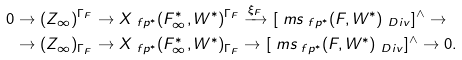Convert formula to latex. <formula><loc_0><loc_0><loc_500><loc_500>0 & \to ( Z _ { \infty } ) ^ { \Gamma _ { F } } \to X _ { \ f p ^ { * } } ( F _ { \infty } ^ { * } , W ^ { * } ) ^ { \Gamma _ { F } } \xrightarrow { \xi _ { F } } [ \ m s _ { \ f p ^ { * } } ( F , W ^ { * } ) _ { \ D i v } ] ^ { \land } \to \\ & \to ( Z _ { \infty } ) _ { \Gamma _ { F } } \to X _ { \ f p ^ { * } } ( F _ { \infty } ^ { * } , W ^ { * } ) _ { \Gamma _ { F } } \to [ \ m s _ { \ f p ^ { * } } ( F , W ^ { * } ) _ { \ D i v } ] ^ { \land } \to 0 .</formula> 